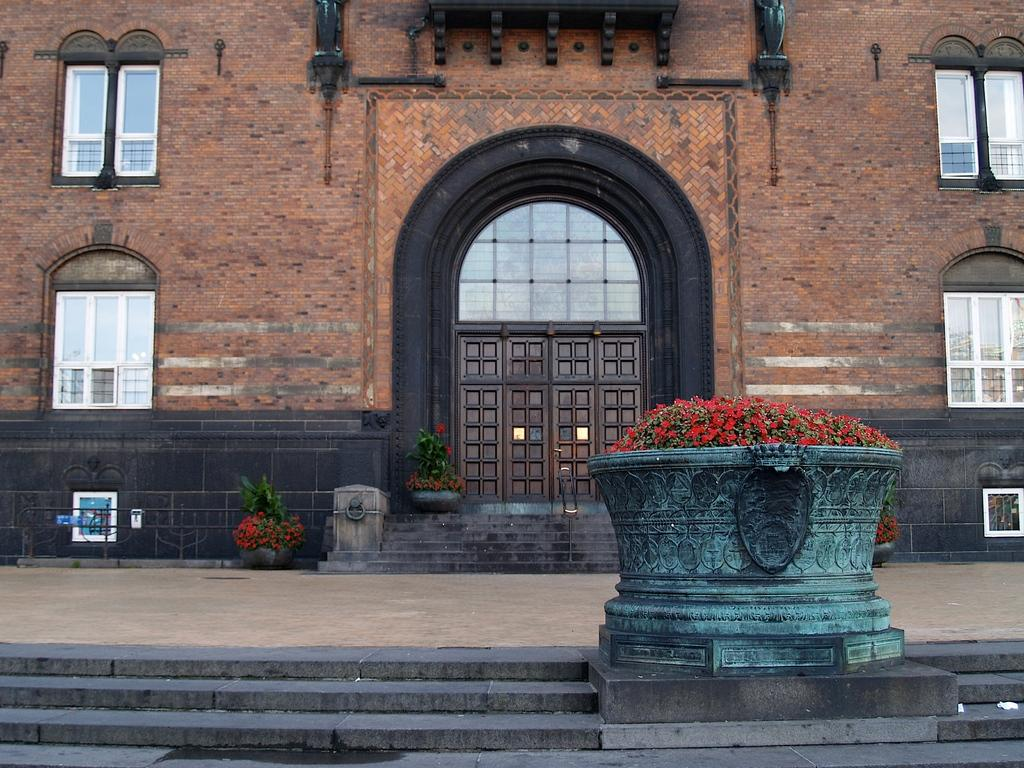What type of living organisms can be seen in the image? Plants and flowers are visible in the image. What architectural features can be seen in the image? There is a fence, steps, a floor, windows, a door, and a building visible in the image. Can you describe the setting where the plants and flowers are located? The plants and flowers are located near a building, with a fence, steps, windows, and a door visible. Is your aunt attacking the building with thunder in the image? There is no mention of an aunt, attack, or thunder in the image. The image features plants, flowers, and various architectural elements, but no such events or individuals are depicted. 